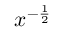Convert formula to latex. <formula><loc_0><loc_0><loc_500><loc_500>x ^ { - { \frac { 1 } { 2 } } }</formula> 